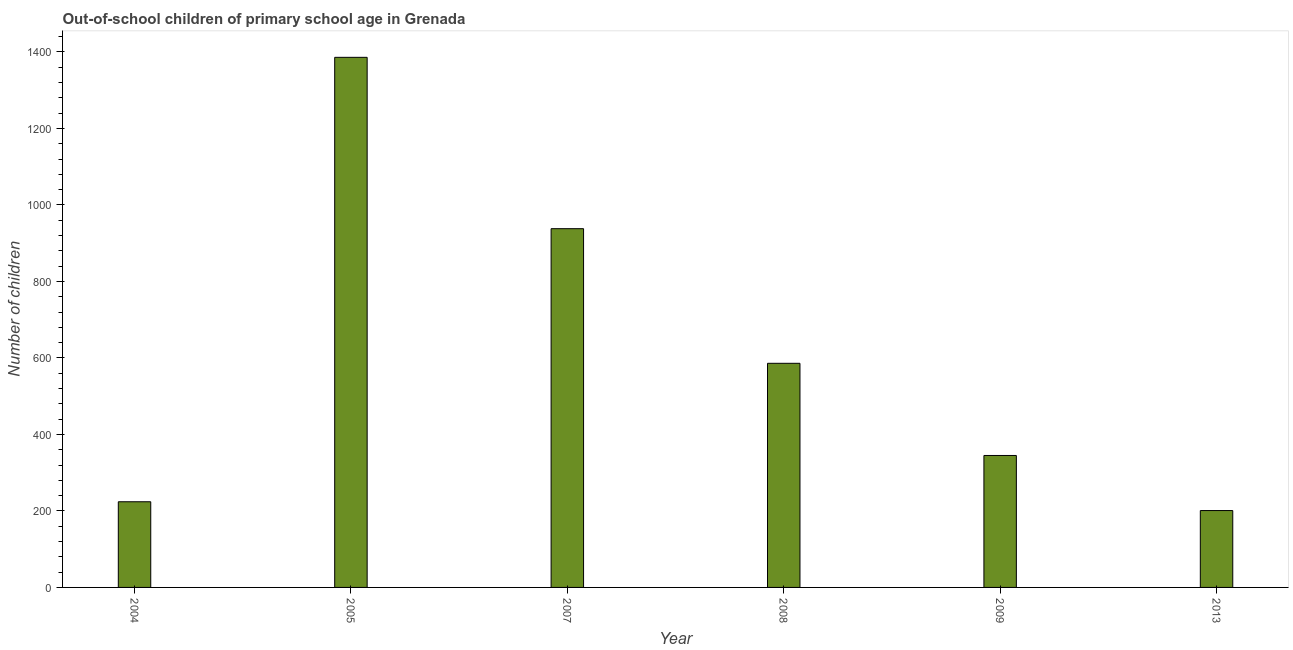Does the graph contain any zero values?
Offer a terse response. No. What is the title of the graph?
Provide a succinct answer. Out-of-school children of primary school age in Grenada. What is the label or title of the Y-axis?
Offer a terse response. Number of children. What is the number of out-of-school children in 2005?
Keep it short and to the point. 1386. Across all years, what is the maximum number of out-of-school children?
Your answer should be very brief. 1386. Across all years, what is the minimum number of out-of-school children?
Keep it short and to the point. 201. In which year was the number of out-of-school children maximum?
Your response must be concise. 2005. In which year was the number of out-of-school children minimum?
Ensure brevity in your answer.  2013. What is the sum of the number of out-of-school children?
Your answer should be very brief. 3680. What is the difference between the number of out-of-school children in 2005 and 2007?
Keep it short and to the point. 448. What is the average number of out-of-school children per year?
Make the answer very short. 613. What is the median number of out-of-school children?
Offer a very short reply. 465.5. What is the ratio of the number of out-of-school children in 2004 to that in 2013?
Offer a very short reply. 1.11. What is the difference between the highest and the second highest number of out-of-school children?
Provide a succinct answer. 448. Is the sum of the number of out-of-school children in 2007 and 2008 greater than the maximum number of out-of-school children across all years?
Give a very brief answer. Yes. What is the difference between the highest and the lowest number of out-of-school children?
Your response must be concise. 1185. In how many years, is the number of out-of-school children greater than the average number of out-of-school children taken over all years?
Your response must be concise. 2. How many bars are there?
Your answer should be compact. 6. Are all the bars in the graph horizontal?
Your answer should be very brief. No. How many years are there in the graph?
Give a very brief answer. 6. What is the difference between two consecutive major ticks on the Y-axis?
Offer a very short reply. 200. Are the values on the major ticks of Y-axis written in scientific E-notation?
Make the answer very short. No. What is the Number of children of 2004?
Keep it short and to the point. 224. What is the Number of children of 2005?
Offer a very short reply. 1386. What is the Number of children of 2007?
Offer a terse response. 938. What is the Number of children in 2008?
Provide a short and direct response. 586. What is the Number of children of 2009?
Give a very brief answer. 345. What is the Number of children of 2013?
Provide a succinct answer. 201. What is the difference between the Number of children in 2004 and 2005?
Your answer should be very brief. -1162. What is the difference between the Number of children in 2004 and 2007?
Ensure brevity in your answer.  -714. What is the difference between the Number of children in 2004 and 2008?
Your answer should be very brief. -362. What is the difference between the Number of children in 2004 and 2009?
Offer a terse response. -121. What is the difference between the Number of children in 2005 and 2007?
Offer a terse response. 448. What is the difference between the Number of children in 2005 and 2008?
Provide a short and direct response. 800. What is the difference between the Number of children in 2005 and 2009?
Give a very brief answer. 1041. What is the difference between the Number of children in 2005 and 2013?
Offer a terse response. 1185. What is the difference between the Number of children in 2007 and 2008?
Your answer should be compact. 352. What is the difference between the Number of children in 2007 and 2009?
Provide a succinct answer. 593. What is the difference between the Number of children in 2007 and 2013?
Give a very brief answer. 737. What is the difference between the Number of children in 2008 and 2009?
Offer a terse response. 241. What is the difference between the Number of children in 2008 and 2013?
Offer a terse response. 385. What is the difference between the Number of children in 2009 and 2013?
Provide a succinct answer. 144. What is the ratio of the Number of children in 2004 to that in 2005?
Offer a terse response. 0.16. What is the ratio of the Number of children in 2004 to that in 2007?
Ensure brevity in your answer.  0.24. What is the ratio of the Number of children in 2004 to that in 2008?
Offer a terse response. 0.38. What is the ratio of the Number of children in 2004 to that in 2009?
Offer a terse response. 0.65. What is the ratio of the Number of children in 2004 to that in 2013?
Your answer should be very brief. 1.11. What is the ratio of the Number of children in 2005 to that in 2007?
Your answer should be compact. 1.48. What is the ratio of the Number of children in 2005 to that in 2008?
Offer a terse response. 2.37. What is the ratio of the Number of children in 2005 to that in 2009?
Make the answer very short. 4.02. What is the ratio of the Number of children in 2005 to that in 2013?
Your answer should be very brief. 6.9. What is the ratio of the Number of children in 2007 to that in 2008?
Offer a terse response. 1.6. What is the ratio of the Number of children in 2007 to that in 2009?
Your answer should be compact. 2.72. What is the ratio of the Number of children in 2007 to that in 2013?
Make the answer very short. 4.67. What is the ratio of the Number of children in 2008 to that in 2009?
Give a very brief answer. 1.7. What is the ratio of the Number of children in 2008 to that in 2013?
Offer a terse response. 2.92. What is the ratio of the Number of children in 2009 to that in 2013?
Your response must be concise. 1.72. 